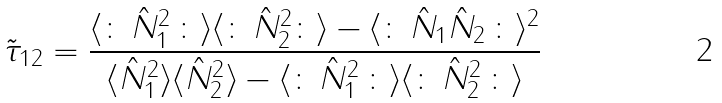<formula> <loc_0><loc_0><loc_500><loc_500>\tilde { \tau } _ { 1 2 } = \frac { \langle \colon \, \hat { N } _ { 1 } ^ { 2 } \, \colon \rangle \langle \colon \, \hat { N } _ { 2 } ^ { 2 } \colon \rangle - \langle \colon \, \hat { N } _ { 1 } \hat { N } _ { 2 } \, \colon \rangle ^ { 2 } } { \langle \hat { N } _ { 1 } ^ { 2 } \rangle \langle \hat { N } _ { 2 } ^ { 2 } \rangle - \langle \colon \, \hat { N } _ { 1 } ^ { 2 } \, \colon \rangle \langle \colon \, \hat { N } _ { 2 } ^ { 2 } \, \colon \rangle }</formula> 